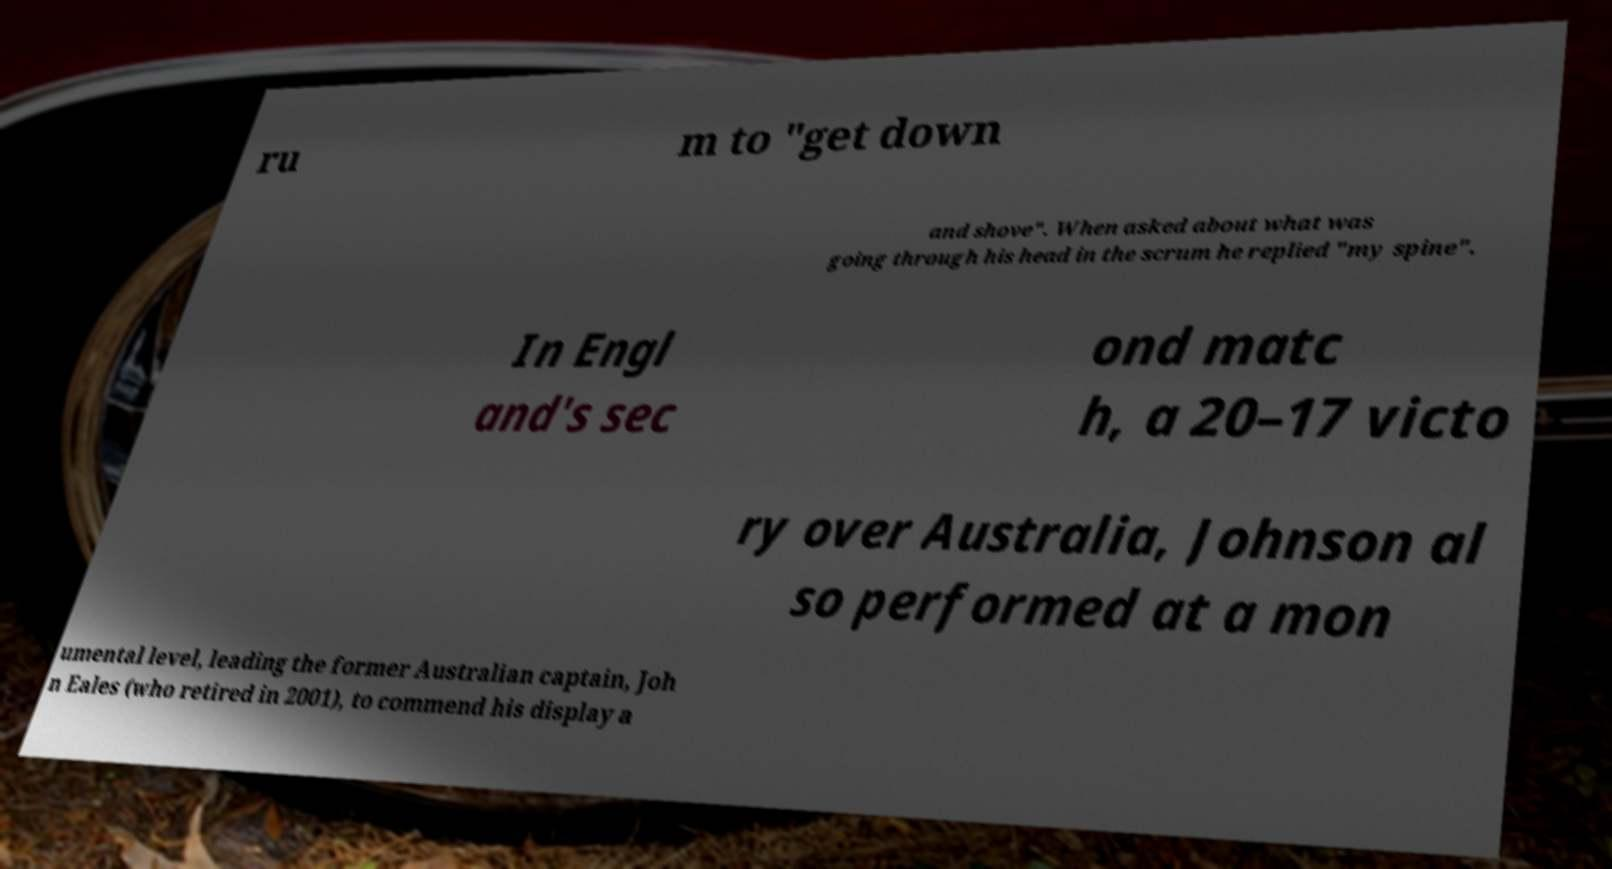Can you read and provide the text displayed in the image?This photo seems to have some interesting text. Can you extract and type it out for me? ru m to "get down and shove". When asked about what was going through his head in the scrum he replied "my spine". In Engl and's sec ond matc h, a 20–17 victo ry over Australia, Johnson al so performed at a mon umental level, leading the former Australian captain, Joh n Eales (who retired in 2001), to commend his display a 